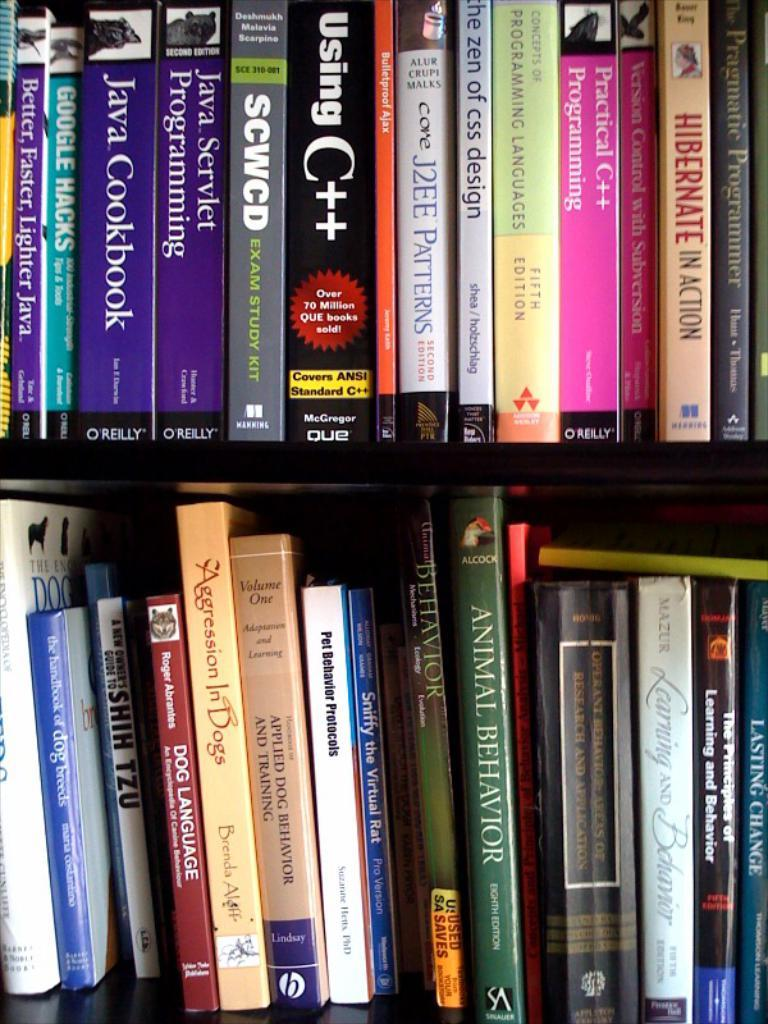<image>
Summarize the visual content of the image. a book shelf with the book Using C++ on it 